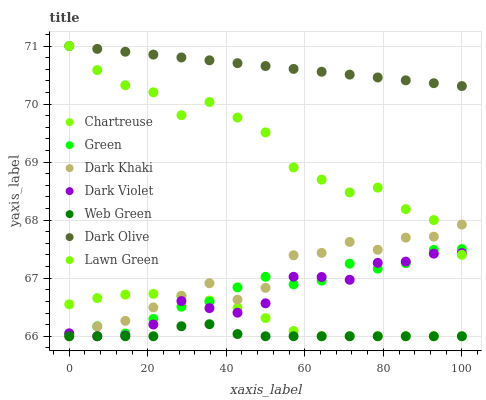Does Web Green have the minimum area under the curve?
Answer yes or no. Yes. Does Dark Olive have the maximum area under the curve?
Answer yes or no. Yes. Does Dark Olive have the minimum area under the curve?
Answer yes or no. No. Does Web Green have the maximum area under the curve?
Answer yes or no. No. Is Dark Olive the smoothest?
Answer yes or no. Yes. Is Lawn Green the roughest?
Answer yes or no. Yes. Is Web Green the smoothest?
Answer yes or no. No. Is Web Green the roughest?
Answer yes or no. No. Does Web Green have the lowest value?
Answer yes or no. Yes. Does Dark Olive have the lowest value?
Answer yes or no. No. Does Dark Olive have the highest value?
Answer yes or no. Yes. Does Web Green have the highest value?
Answer yes or no. No. Is Chartreuse less than Dark Olive?
Answer yes or no. Yes. Is Dark Olive greater than Dark Khaki?
Answer yes or no. Yes. Does Green intersect Dark Violet?
Answer yes or no. Yes. Is Green less than Dark Violet?
Answer yes or no. No. Is Green greater than Dark Violet?
Answer yes or no. No. Does Chartreuse intersect Dark Olive?
Answer yes or no. No. 